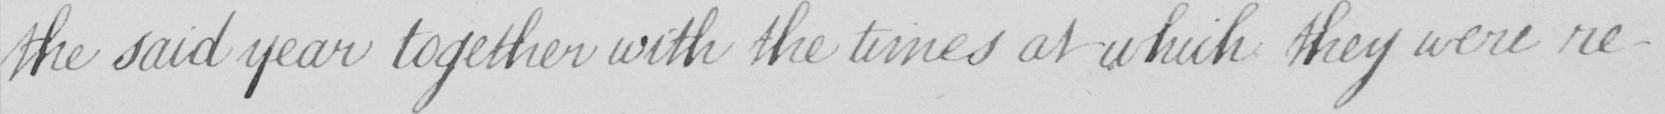What text is written in this handwritten line? the said year together with the times at which they were re- 